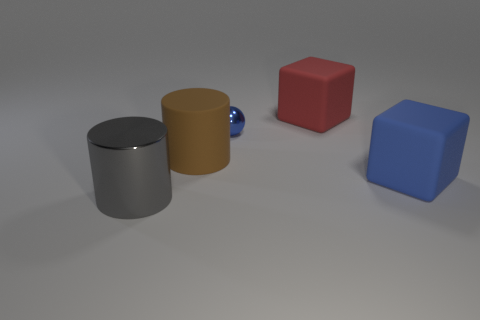What number of cylinders are the same color as the ball?
Offer a terse response. 0. Are there any metal balls that are left of the blue object that is behind the matte object that is in front of the brown cylinder?
Your answer should be compact. No. There is a gray shiny object that is the same size as the red thing; what shape is it?
Your answer should be very brief. Cylinder. What number of small things are red rubber cubes or shiny cylinders?
Make the answer very short. 0. There is a cylinder that is the same material as the big blue cube; what is its color?
Provide a short and direct response. Brown. Does the metal thing to the right of the gray shiny object have the same shape as the large thing that is to the left of the big brown matte object?
Ensure brevity in your answer.  No. How many rubber things are either brown cylinders or big green cylinders?
Your answer should be compact. 1. There is a cube that is the same color as the small object; what is its material?
Offer a terse response. Rubber. Is there any other thing that is the same shape as the tiny metal thing?
Offer a very short reply. No. There is a blue thing that is behind the big matte cylinder; what is its material?
Give a very brief answer. Metal. 